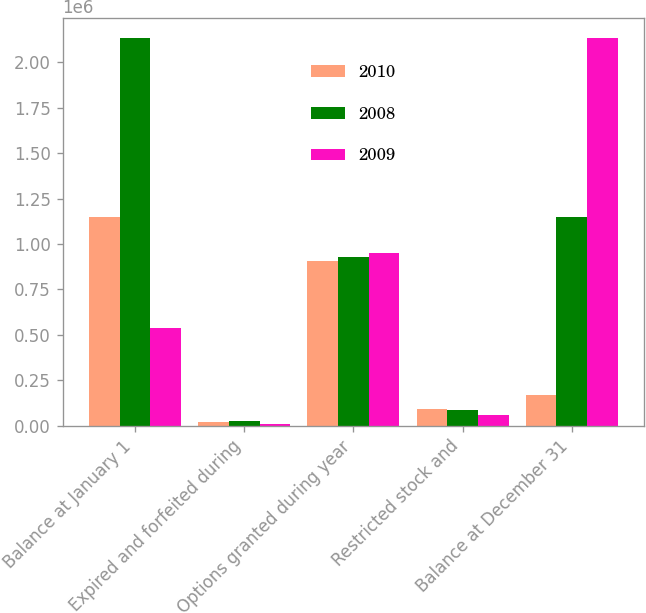Convert chart. <chart><loc_0><loc_0><loc_500><loc_500><stacked_bar_chart><ecel><fcel>Balance at January 1<fcel>Expired and forfeited during<fcel>Options granted during year<fcel>Restricted stock and<fcel>Balance at December 31<nl><fcel>2010<fcel>1.14969e+06<fcel>17513<fcel>905450<fcel>91580<fcel>170176<nl><fcel>2008<fcel>2.13681e+06<fcel>25000<fcel>928850<fcel>83263<fcel>1.14969e+06<nl><fcel>2009<fcel>537813<fcel>8000<fcel>949750<fcel>57444<fcel>2.13681e+06<nl></chart> 